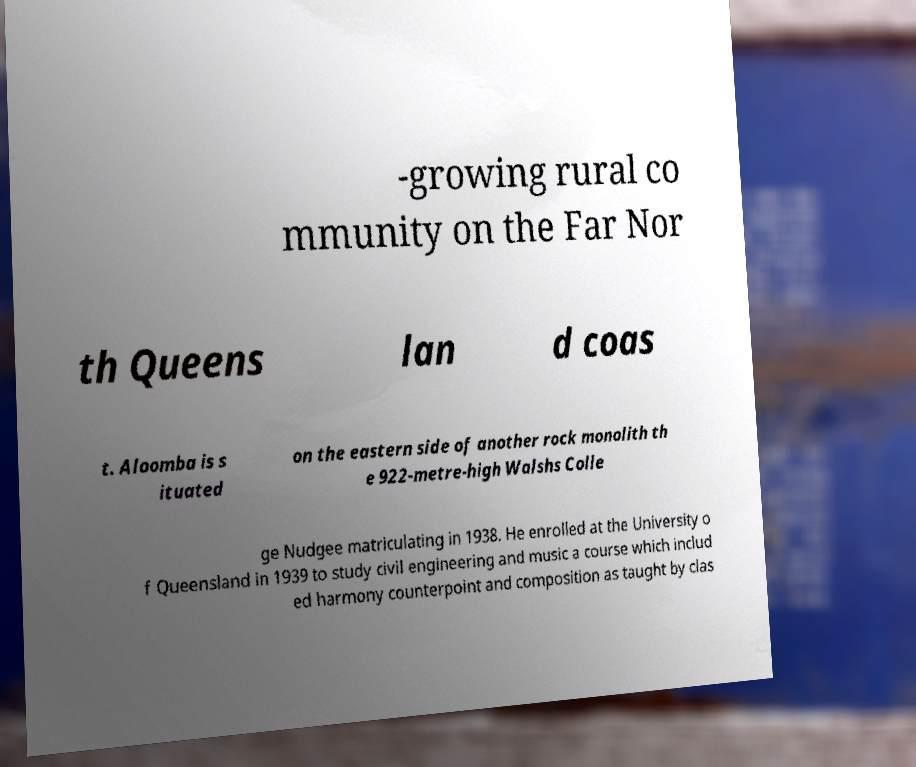For documentation purposes, I need the text within this image transcribed. Could you provide that? -growing rural co mmunity on the Far Nor th Queens lan d coas t. Aloomba is s ituated on the eastern side of another rock monolith th e 922-metre-high Walshs Colle ge Nudgee matriculating in 1938. He enrolled at the University o f Queensland in 1939 to study civil engineering and music a course which includ ed harmony counterpoint and composition as taught by clas 